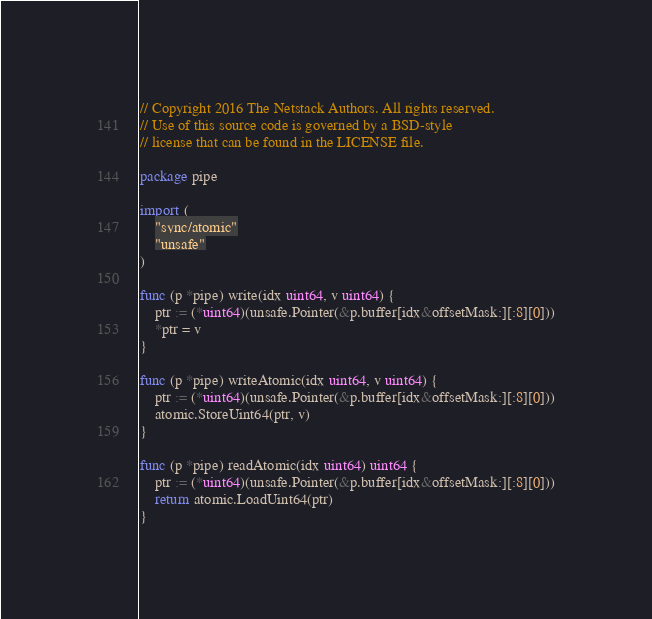Convert code to text. <code><loc_0><loc_0><loc_500><loc_500><_Go_>// Copyright 2016 The Netstack Authors. All rights reserved.
// Use of this source code is governed by a BSD-style
// license that can be found in the LICENSE file.

package pipe

import (
	"sync/atomic"
	"unsafe"
)

func (p *pipe) write(idx uint64, v uint64) {
	ptr := (*uint64)(unsafe.Pointer(&p.buffer[idx&offsetMask:][:8][0]))
	*ptr = v
}

func (p *pipe) writeAtomic(idx uint64, v uint64) {
	ptr := (*uint64)(unsafe.Pointer(&p.buffer[idx&offsetMask:][:8][0]))
	atomic.StoreUint64(ptr, v)
}

func (p *pipe) readAtomic(idx uint64) uint64 {
	ptr := (*uint64)(unsafe.Pointer(&p.buffer[idx&offsetMask:][:8][0]))
	return atomic.LoadUint64(ptr)
}
</code> 